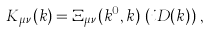Convert formula to latex. <formula><loc_0><loc_0><loc_500><loc_500>K _ { \mu \nu } ( k ) = \Xi _ { \mu \nu } ( k ^ { 0 } , k ) \, \left ( i D ( k ) \right ) \, ,</formula> 